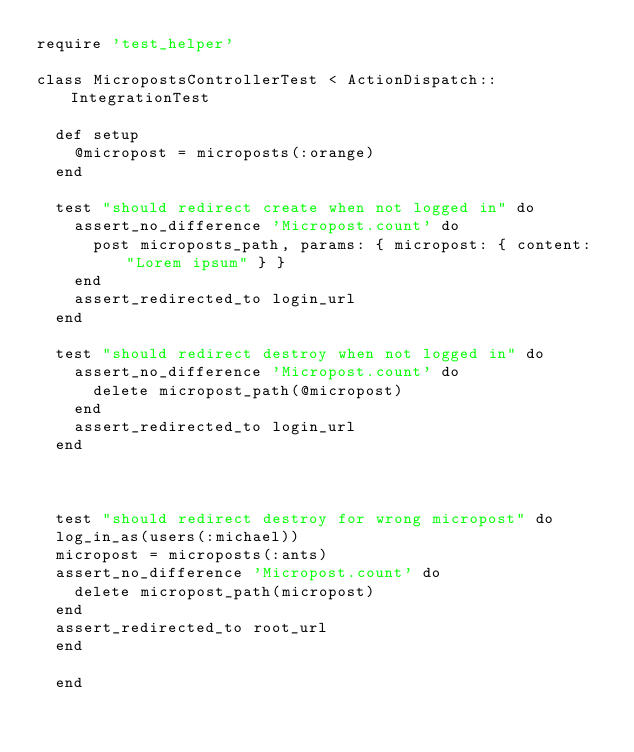<code> <loc_0><loc_0><loc_500><loc_500><_Ruby_>require 'test_helper'

class MicropostsControllerTest < ActionDispatch::IntegrationTest

  def setup
    @micropost = microposts(:orange)
  end

  test "should redirect create when not logged in" do
    assert_no_difference 'Micropost.count' do
      post microposts_path, params: { micropost: { content: "Lorem ipsum" } }
    end
    assert_redirected_to login_url
  end

  test "should redirect destroy when not logged in" do
    assert_no_difference 'Micropost.count' do
      delete micropost_path(@micropost)
    end
    assert_redirected_to login_url
  end



  test "should redirect destroy for wrong micropost" do
  log_in_as(users(:michael))
  micropost = microposts(:ants)
  assert_no_difference 'Micropost.count' do
    delete micropost_path(micropost)
  end
  assert_redirected_to root_url
  end

  end</code> 